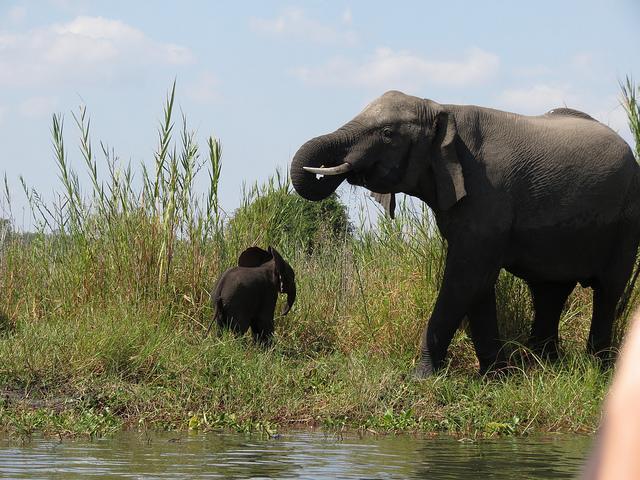How many animals are shown?
Give a very brief answer. 2. How many elephants are male?
Give a very brief answer. 1. How many elephants are there?
Give a very brief answer. 2. How many buses are there?
Give a very brief answer. 0. 